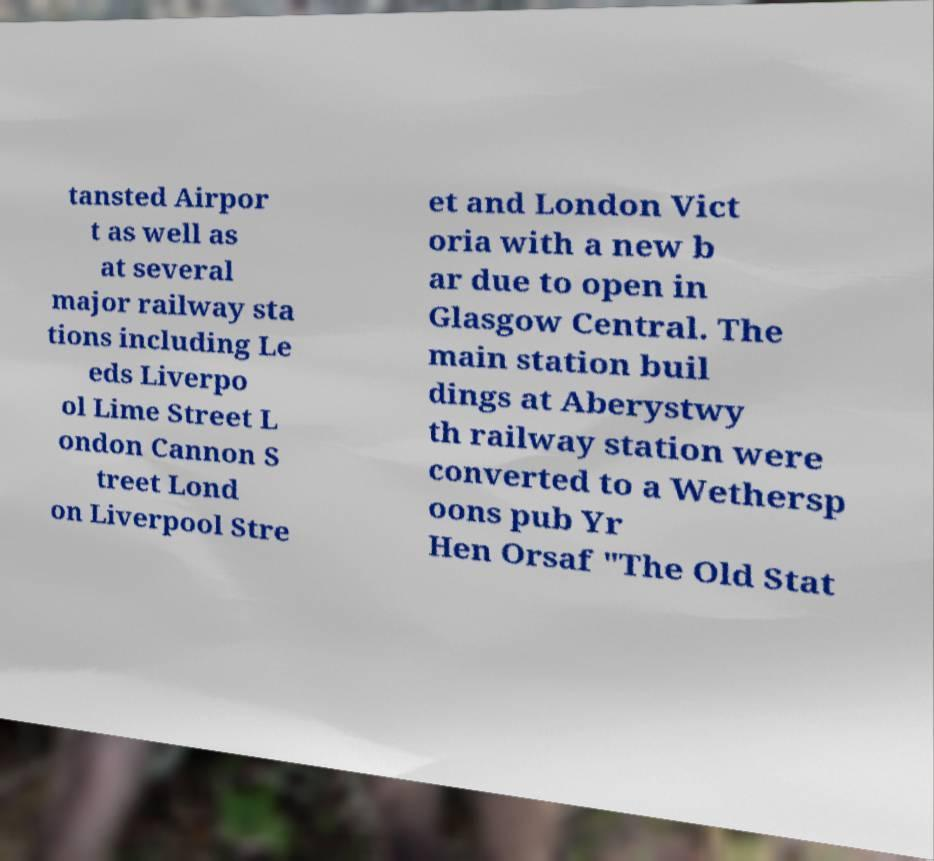For documentation purposes, I need the text within this image transcribed. Could you provide that? tansted Airpor t as well as at several major railway sta tions including Le eds Liverpo ol Lime Street L ondon Cannon S treet Lond on Liverpool Stre et and London Vict oria with a new b ar due to open in Glasgow Central. The main station buil dings at Aberystwy th railway station were converted to a Wethersp oons pub Yr Hen Orsaf "The Old Stat 